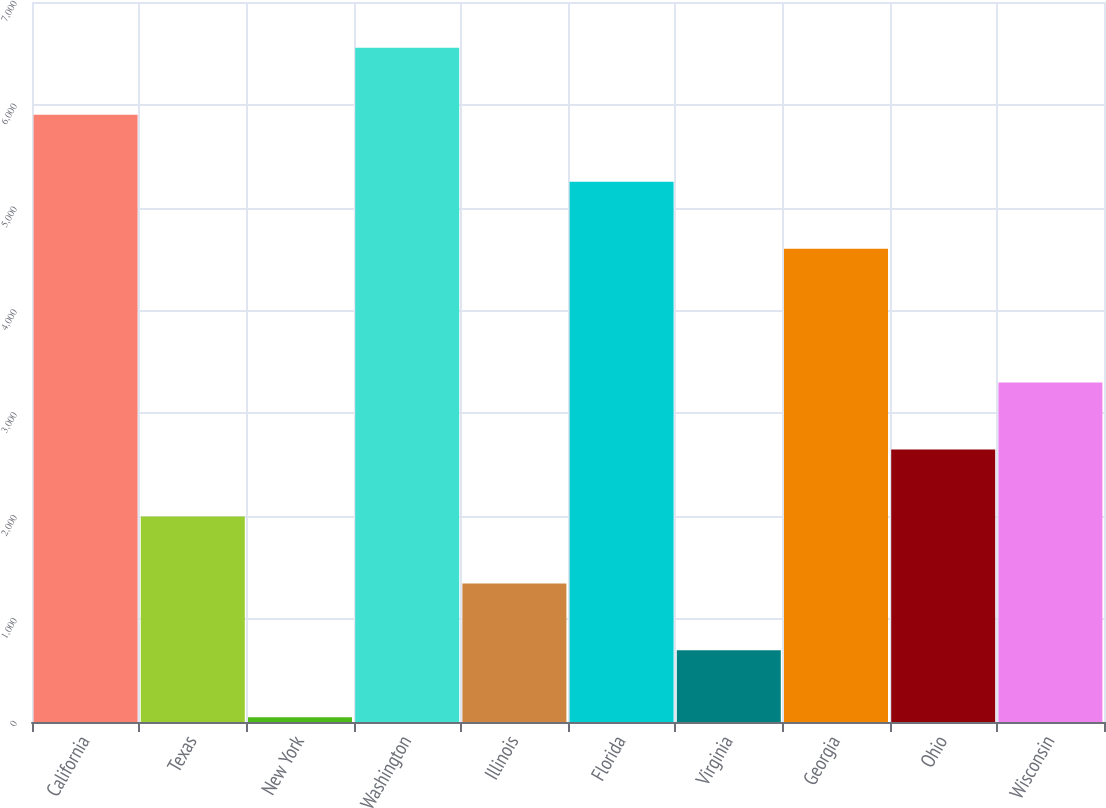Convert chart. <chart><loc_0><loc_0><loc_500><loc_500><bar_chart><fcel>California<fcel>Texas<fcel>New York<fcel>Washington<fcel>Illinois<fcel>Florida<fcel>Virginia<fcel>Georgia<fcel>Ohio<fcel>Wisconsin<nl><fcel>5903.2<fcel>1998.4<fcel>46<fcel>6554<fcel>1347.6<fcel>5252.4<fcel>696.8<fcel>4601.6<fcel>2649.2<fcel>3300<nl></chart> 